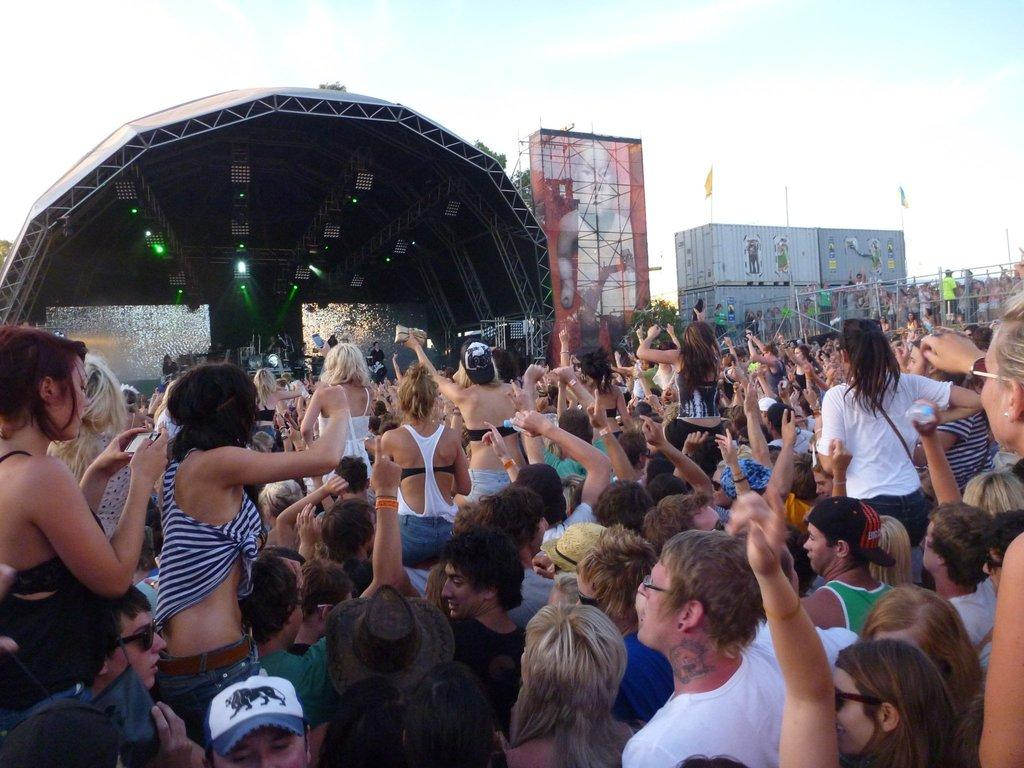How many people are present in the image? There are many people in the image. What can be seen in the background behind the people? There is a stage with lights and buildings in the background. Are there any flags visible in the image? Yes, there are flags in the image. What is visible in the sky in the background? The sky with clouds is visible in the background. What type of bag is being used for arithmetic calculations in the image? There is no bag or arithmetic calculations present in the image. 